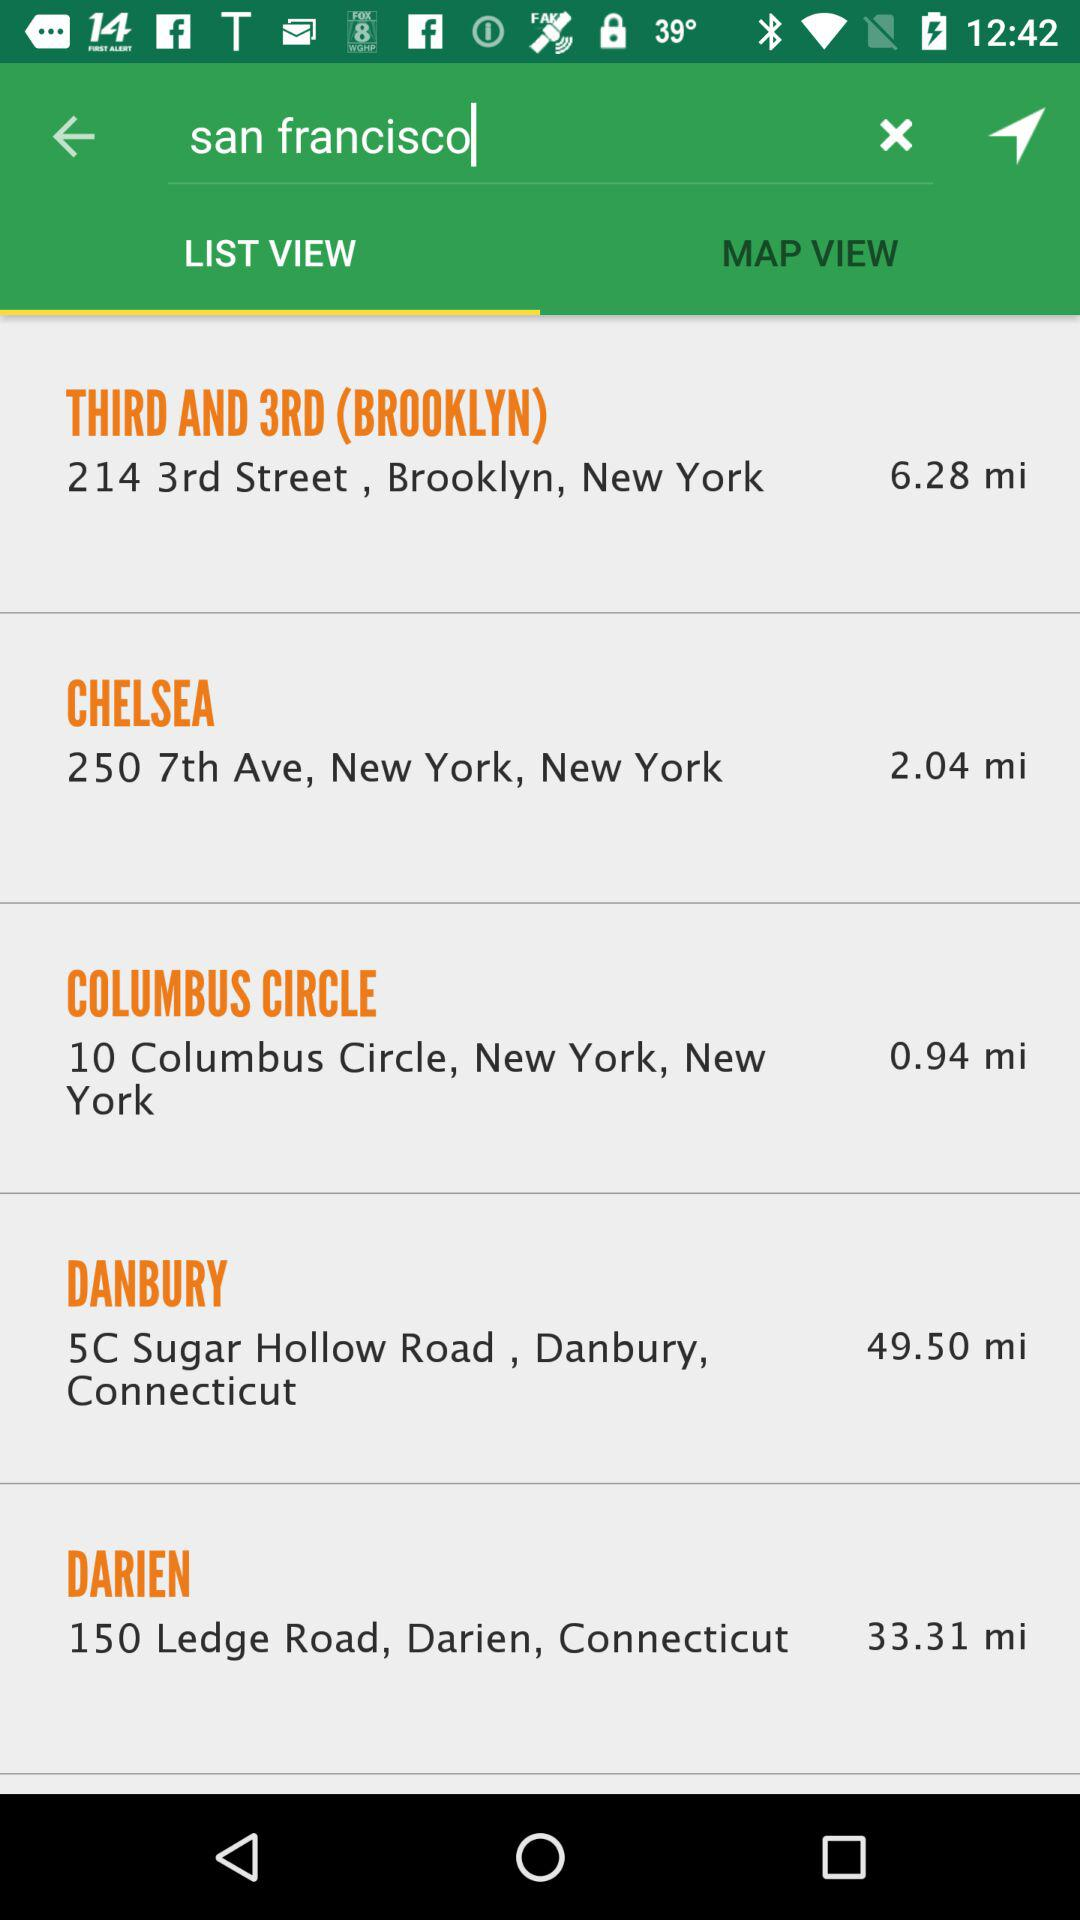Which tab is selected? The selected tab is "LIST VIEW". 